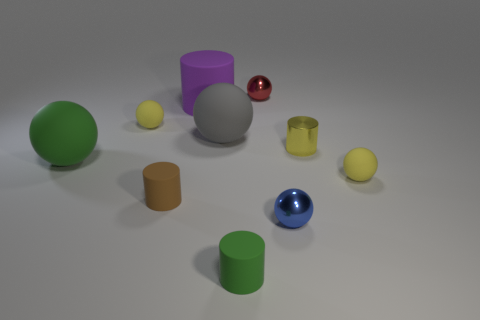What is the material of the green object in front of the green matte sphere?
Your answer should be very brief. Rubber. There is a yellow thing that is the same shape as the brown object; what is its size?
Offer a very short reply. Small. How many spheres have the same material as the brown cylinder?
Ensure brevity in your answer.  4. What number of small matte balls are the same color as the metal cylinder?
Your response must be concise. 2. How many things are either tiny rubber spheres that are to the left of the purple matte cylinder or green things that are in front of the gray rubber thing?
Ensure brevity in your answer.  3. Is the number of objects that are on the right side of the big cylinder less than the number of small brown cylinders?
Provide a succinct answer. No. Are there any gray matte balls of the same size as the purple rubber thing?
Make the answer very short. Yes. The shiny cylinder is what color?
Offer a terse response. Yellow. Does the red sphere have the same size as the green sphere?
Offer a terse response. No. What number of things are either purple matte objects or blue rubber balls?
Your answer should be very brief. 1. 